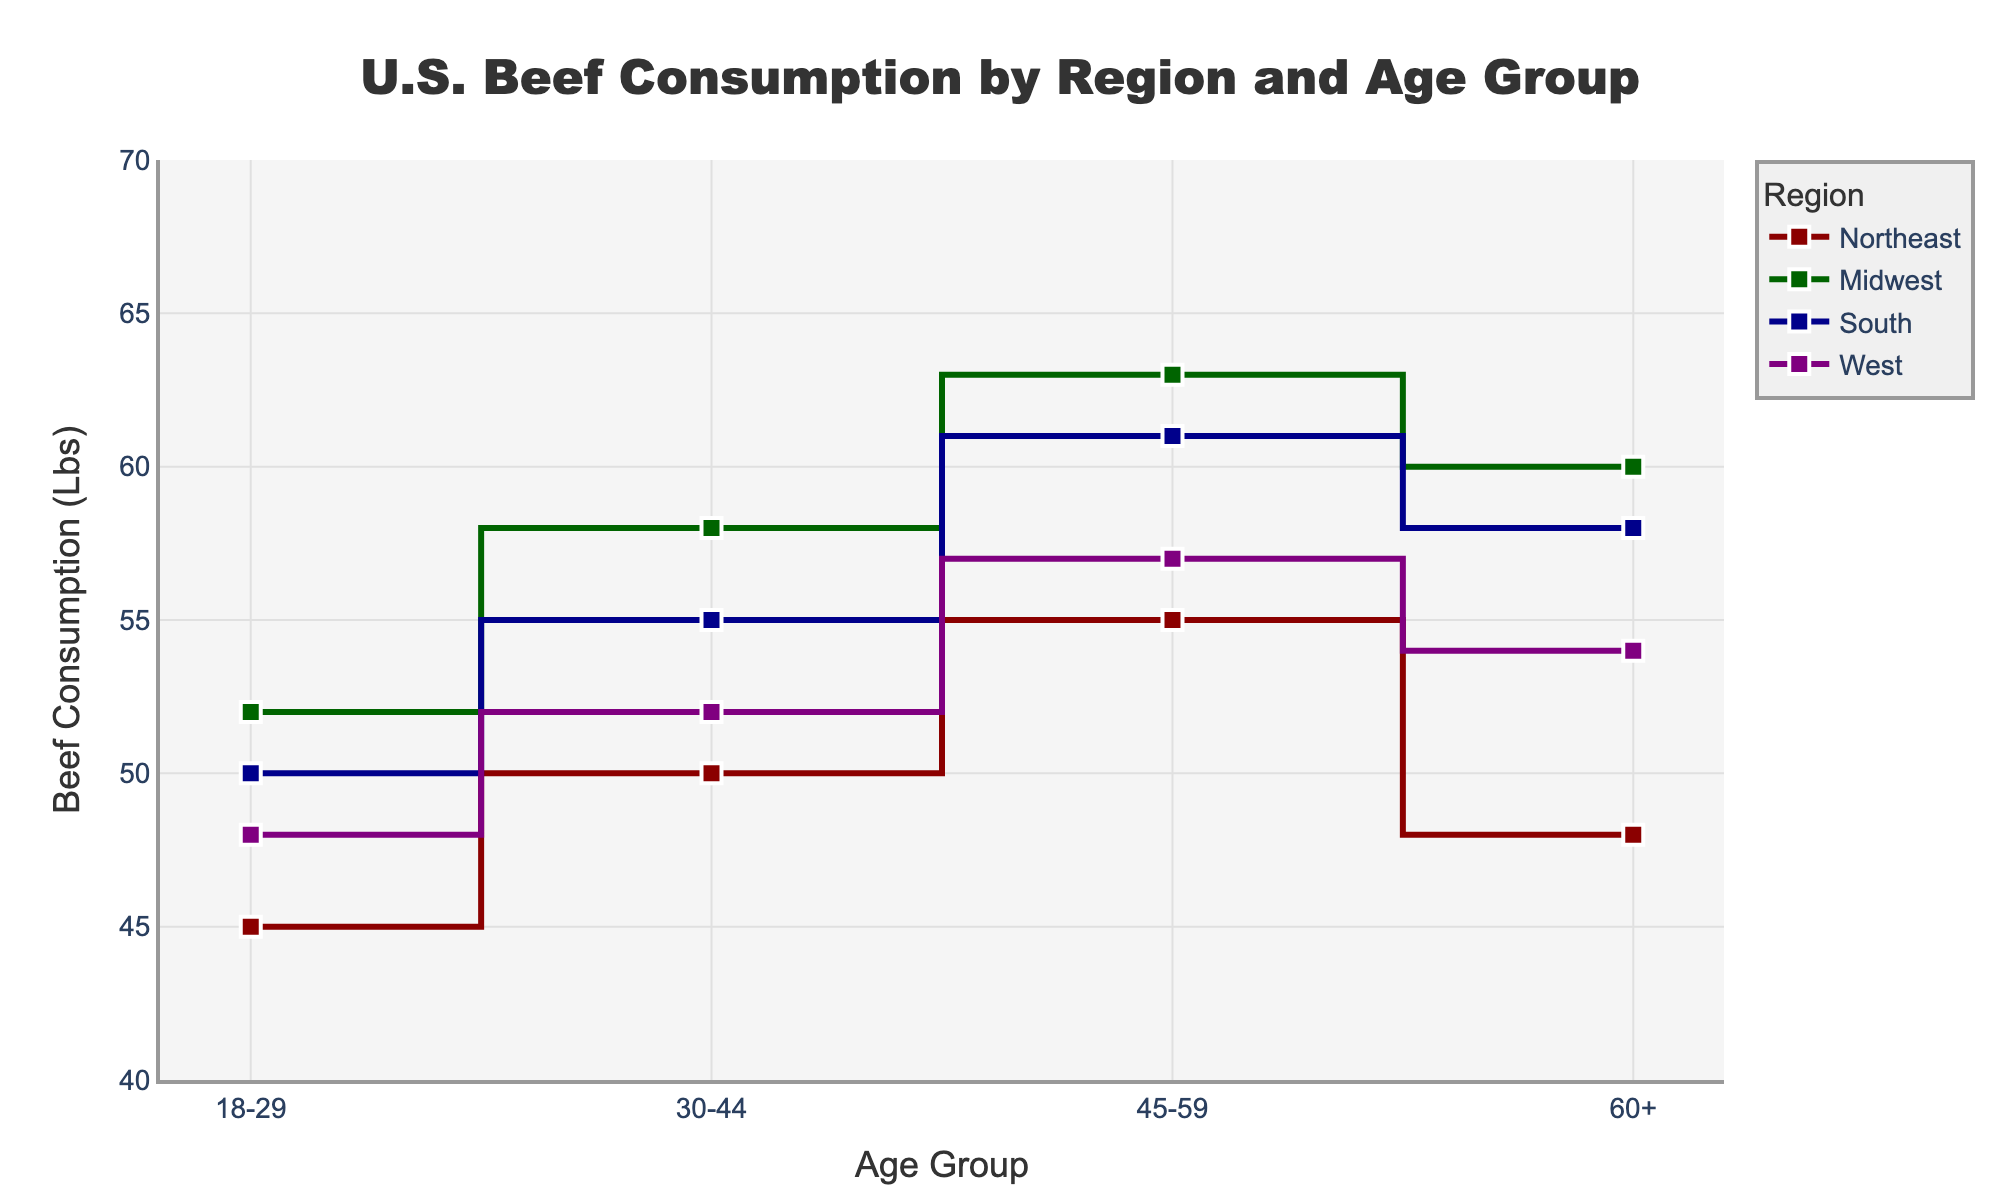Which region has the highest beef consumption among the 30-44 age group? By examining the lines corresponding to each region for the 30-44 age group, we see that the Midwest region has the highest beef consumption level of 58 lbs.
Answer: Midwest How does beef consumption in the South for the 45-59 age group compare to the West? For the 45-59 age group, the South region has a beef consumption level of 61 lbs, while the West region has 57 lbs, making the South's consumption higher.
Answer: South has higher consumption What is the total beef consumption across all age groups in the Midwest region? Sum the beef consumption values for all age groups within the Midwest region, which are 52, 58, 63, and 60. The total is 52 + 58 + 63 + 60 = 233 lbs.
Answer: 233 lbs Which age group in the Northeast consumes the least amount of beef? By checking the data for the Northeast region, we find beef consumption levels of 45, 50, 55, and 48 lbs. The 18-29 age group has the lowest at 45 lbs.
Answer: 18-29 Between the South and Northeast regions, which one shows a larger increase in beef consumption from the 18-29 to the 45-59 age group? The increase for the South is from 50 to 61 lbs, a difference of 11 lbs. For the Northeast, the increase is from 45 to 55 lbs, a difference of 10 lbs. Thus, the South shows a larger increase.
Answer: South What is the average beef consumption for the 60+ age group across all regions? Calculate the average by summing the values for each region in the 60+ age group (Northeast: 48, Midwest: 60, South: 58, West: 54), and then divide by the number of regions. (48 + 60 + 58 + 54) / 4 = 220 / 4 = 55 lbs.
Answer: 55 lbs Looking at the plot, which region has the most consistent beef consumption across all age groups? The Midwest region shows the least variation in beef consumption levels, ranging only from 52 to 63 lbs, making it the most consistent comparatively.
Answer: Midwest Is there any age group where all regions have beef consumption above 50 lbs? For the 45-59 age group, all regions show beef consumption above 50 lbs: Northeast (55), Midwest (63), South (61), and West (57).
Answer: Yes, 45-59 